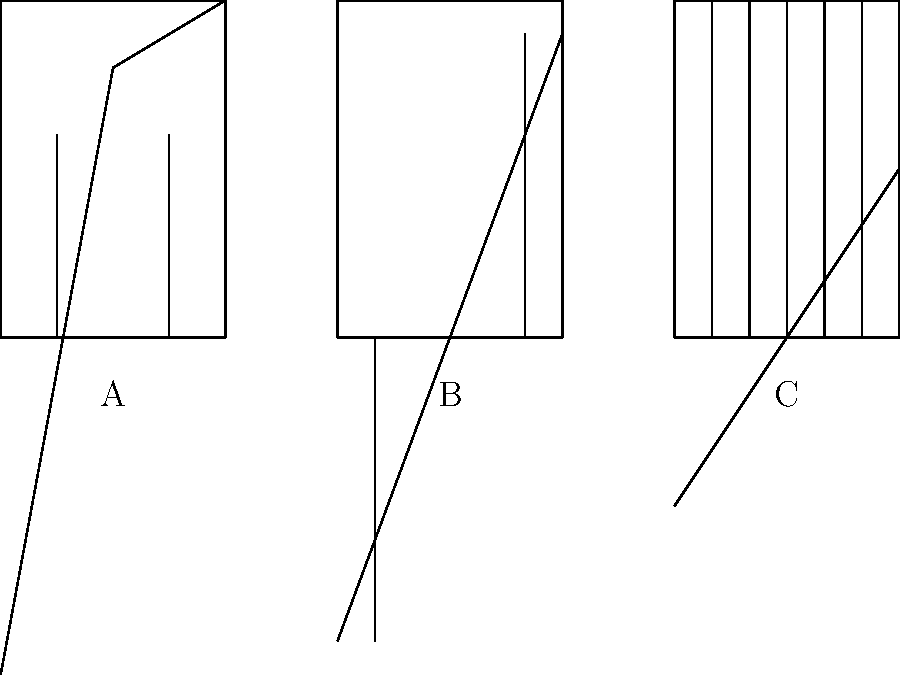Based on your extensive research of hotel architectural styles, which of the hotel facades (A, B, or C) most likely represents an Art Deco style from the 1920s and 1930s? To identify the Art Deco style hotel facade, we need to consider the key characteristics of this architectural movement from the 1920s and 1930s:

1. Art Deco is characterized by geometric shapes and streamlined forms.
2. It often features symmetrical designs with vertical emphasis.
3. Decorative elements are typically stylized and geometric rather than ornate.

Now, let's analyze each facade:

A. This facade shows a triangular roof and ornate window frames, typical of Victorian architecture (late 19th century). It's not Art Deco.

B. This facade displays:
   - A flat roof
   - Strong vertical lines
   - Geometric shapes and symmetry
   These are all hallmarks of Art Deco style.

C. This facade has large glass panels and a minimalist design, indicative of Modern architecture (mid-20th century onwards). It's not Art Deco.

Therefore, based on these characteristics, the hotel facade that most likely represents an Art Deco style from the 1920s and 1930s is B.
Answer: B 